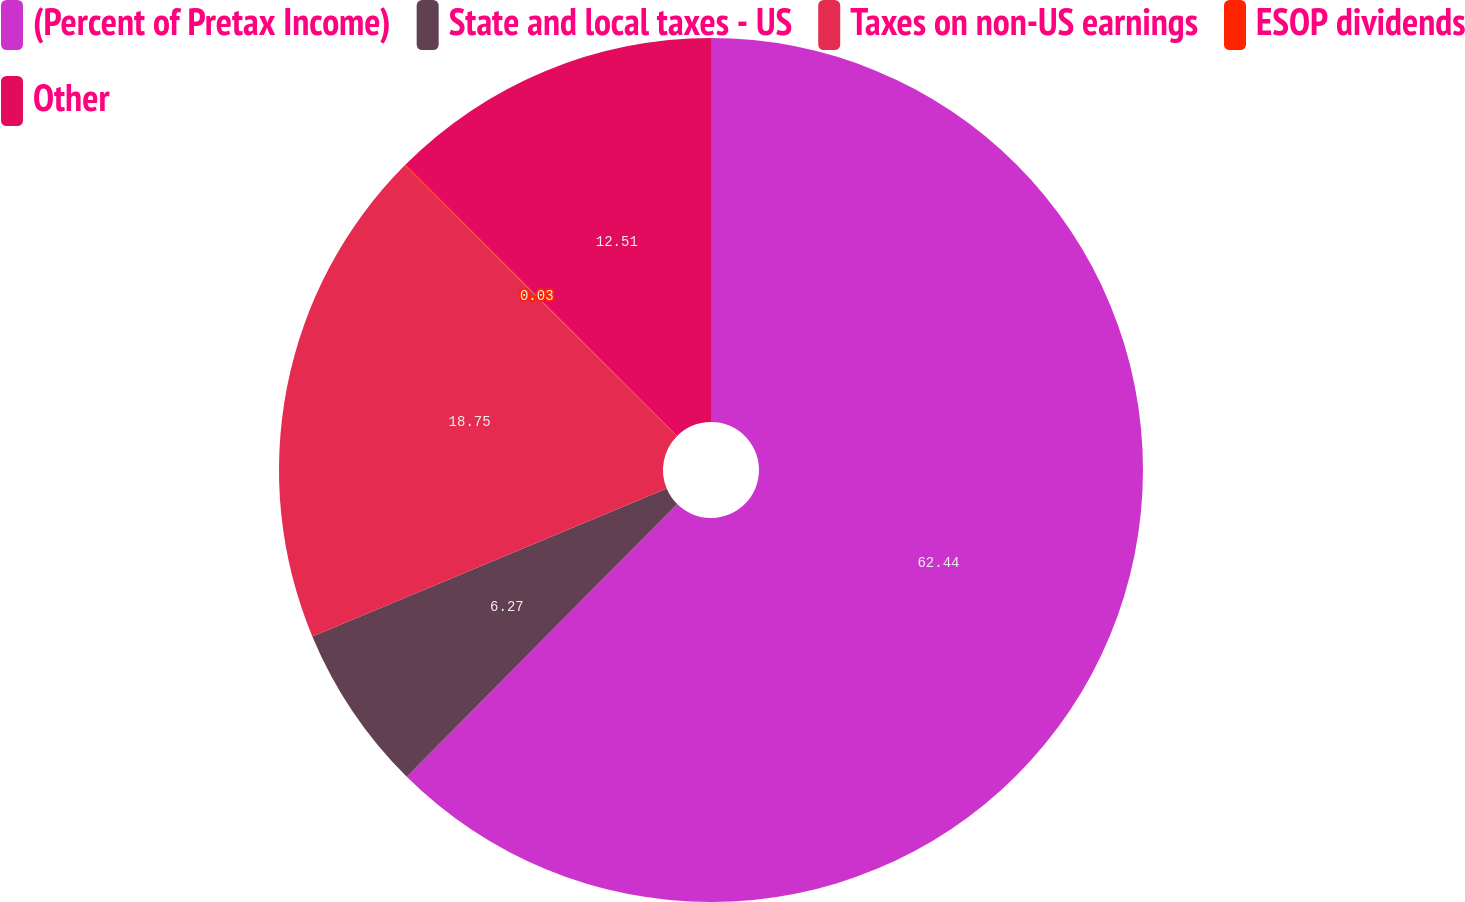Convert chart to OTSL. <chart><loc_0><loc_0><loc_500><loc_500><pie_chart><fcel>(Percent of Pretax Income)<fcel>State and local taxes - US<fcel>Taxes on non-US earnings<fcel>ESOP dividends<fcel>Other<nl><fcel>62.43%<fcel>6.27%<fcel>18.75%<fcel>0.03%<fcel>12.51%<nl></chart> 